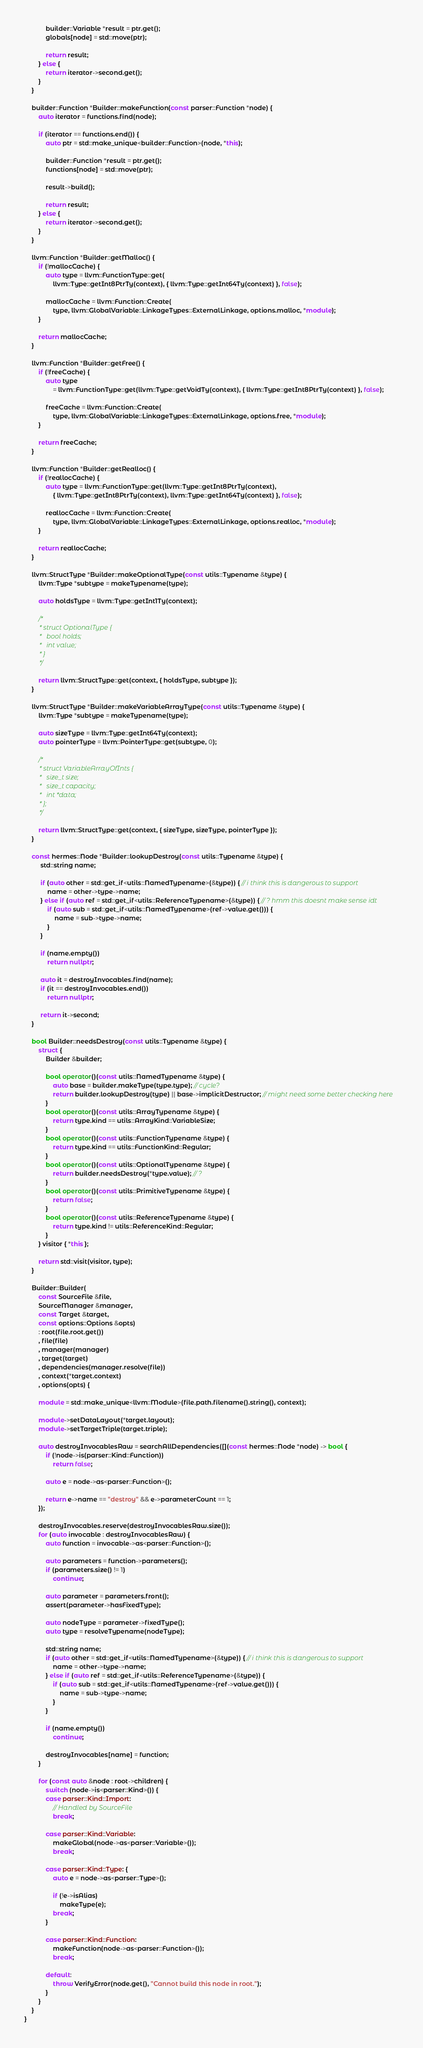<code> <loc_0><loc_0><loc_500><loc_500><_C++_>            builder::Variable *result = ptr.get();
            globals[node] = std::move(ptr);

            return result;
        } else {
            return iterator->second.get();
        }
    }

    builder::Function *Builder::makeFunction(const parser::Function *node) {
        auto iterator = functions.find(node);

        if (iterator == functions.end()) {
            auto ptr = std::make_unique<builder::Function>(node, *this);

            builder::Function *result = ptr.get();
            functions[node] = std::move(ptr);

            result->build();

            return result;
        } else {
            return iterator->second.get();
        }
    }

    llvm::Function *Builder::getMalloc() {
        if (!mallocCache) {
            auto type = llvm::FunctionType::get(
                llvm::Type::getInt8PtrTy(context), { llvm::Type::getInt64Ty(context) }, false);

            mallocCache = llvm::Function::Create(
                type, llvm::GlobalVariable::LinkageTypes::ExternalLinkage, options.malloc, *module);
        }

        return mallocCache;
    }

    llvm::Function *Builder::getFree() {
        if (!freeCache) {
            auto type
                = llvm::FunctionType::get(llvm::Type::getVoidTy(context), { llvm::Type::getInt8PtrTy(context) }, false);

            freeCache = llvm::Function::Create(
                type, llvm::GlobalVariable::LinkageTypes::ExternalLinkage, options.free, *module);
        }

        return freeCache;
    }

    llvm::Function *Builder::getRealloc() {
        if (!reallocCache) {
            auto type = llvm::FunctionType::get(llvm::Type::getInt8PtrTy(context),
                { llvm::Type::getInt8PtrTy(context), llvm::Type::getInt64Ty(context) }, false);

            reallocCache = llvm::Function::Create(
                type, llvm::GlobalVariable::LinkageTypes::ExternalLinkage, options.realloc, *module);
        }

        return reallocCache;
    }

    llvm::StructType *Builder::makeOptionalType(const utils::Typename &type) {
        llvm::Type *subtype = makeTypename(type);

        auto holdsType = llvm::Type::getInt1Ty(context);

        /*
         * struct OptionalType {
         *   bool holds;
         *   int value;
         * }
         */

        return llvm::StructType::get(context, { holdsType, subtype });
    }

    llvm::StructType *Builder::makeVariableArrayType(const utils::Typename &type) {
        llvm::Type *subtype = makeTypename(type);

        auto sizeType = llvm::Type::getInt64Ty(context);
        auto pointerType = llvm::PointerType::get(subtype, 0);

        /*
         * struct VariableArrayOfInts {
         *   size_t size;
         *   size_t capacity;
         *   int *data;
         * };
         */

        return llvm::StructType::get(context, { sizeType, sizeType, pointerType });
    }

    const hermes::Node *Builder::lookupDestroy(const utils::Typename &type) {
         std::string name;

         if (auto other = std::get_if<utils::NamedTypename>(&type)) { // i think this is dangerous to support
             name = other->type->name;
         } else if (auto ref = std::get_if<utils::ReferenceTypename>(&type)) { // ? hmm this doesnt make sense idt
             if (auto sub = std::get_if<utils::NamedTypename>(ref->value.get())) {
                 name = sub->type->name;
             }
         }

         if (name.empty())
             return nullptr;

         auto it = destroyInvocables.find(name);
         if (it == destroyInvocables.end())
             return nullptr;

         return it->second;
    }

    bool Builder::needsDestroy(const utils::Typename &type) {
        struct {
            Builder &builder;

            bool operator()(const utils::NamedTypename &type) {
                auto base = builder.makeType(type.type); // cycle?
                return builder.lookupDestroy(type) || base->implicitDestructor; // might need some better checking here
            }
            bool operator()(const utils::ArrayTypename &type) {
                return type.kind == utils::ArrayKind::VariableSize;
            }
            bool operator()(const utils::FunctionTypename &type) {
                return type.kind == utils::FunctionKind::Regular;
            }
            bool operator()(const utils::OptionalTypename &type) {
                return builder.needsDestroy(*type.value); // ?
            }
            bool operator()(const utils::PrimitiveTypename &type) {
                return false;
            }
            bool operator()(const utils::ReferenceTypename &type) {
                return type.kind != utils::ReferenceKind::Regular;
            }
        } visitor { *this };

        return std::visit(visitor, type);
    }

    Builder::Builder(
        const SourceFile &file,
        SourceManager &manager,
        const Target &target,
        const options::Options &opts)
        : root(file.root.get())
        , file(file)
        , manager(manager)
        , target(target)
        , dependencies(manager.resolve(file))
        , context(*target.context)
        , options(opts) {

        module = std::make_unique<llvm::Module>(file.path.filename().string(), context);

        module->setDataLayout(*target.layout);
        module->setTargetTriple(target.triple);

        auto destroyInvocablesRaw = searchAllDependencies([](const hermes::Node *node) -> bool {
            if (!node->is(parser::Kind::Function))
                return false;

            auto e = node->as<parser::Function>();

            return e->name == "destroy" && e->parameterCount == 1;
        });

        destroyInvocables.reserve(destroyInvocablesRaw.size());
        for (auto invocable : destroyInvocablesRaw) {
            auto function = invocable->as<parser::Function>();

            auto parameters = function->parameters();
            if (parameters.size() != 1)
                continue;

            auto parameter = parameters.front();
            assert(parameter->hasFixedType);

            auto nodeType = parameter->fixedType();
            auto type = resolveTypename(nodeType);

            std::string name;
            if (auto other = std::get_if<utils::NamedTypename>(&type)) { // i think this is dangerous to support
                name = other->type->name;
            } else if (auto ref = std::get_if<utils::ReferenceTypename>(&type)) {
                if (auto sub = std::get_if<utils::NamedTypename>(ref->value.get())) {
                    name = sub->type->name;
                }
            }

            if (name.empty())
                continue;

            destroyInvocables[name] = function;
        }

        for (const auto &node : root->children) {
            switch (node->is<parser::Kind>()) {
            case parser::Kind::Import:
                // Handled by SourceFile
                break;

            case parser::Kind::Variable:
                makeGlobal(node->as<parser::Variable>());
                break;

            case parser::Kind::Type: {
                auto e = node->as<parser::Type>();

                if (!e->isAlias)
                    makeType(e);
                break;
            }

            case parser::Kind::Function:
                makeFunction(node->as<parser::Function>());
                break;

            default:
                throw VerifyError(node.get(), "Cannot build this node in root.");
            }
        }
    }
}
</code> 